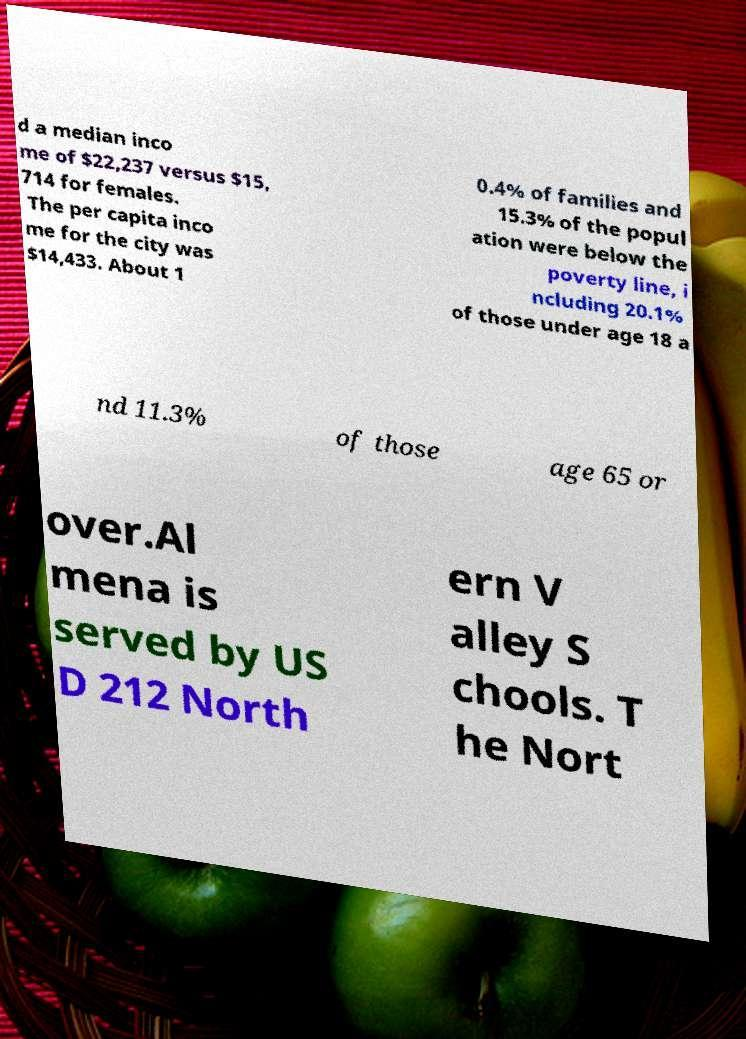Can you accurately transcribe the text from the provided image for me? d a median inco me of $22,237 versus $15, 714 for females. The per capita inco me for the city was $14,433. About 1 0.4% of families and 15.3% of the popul ation were below the poverty line, i ncluding 20.1% of those under age 18 a nd 11.3% of those age 65 or over.Al mena is served by US D 212 North ern V alley S chools. T he Nort 